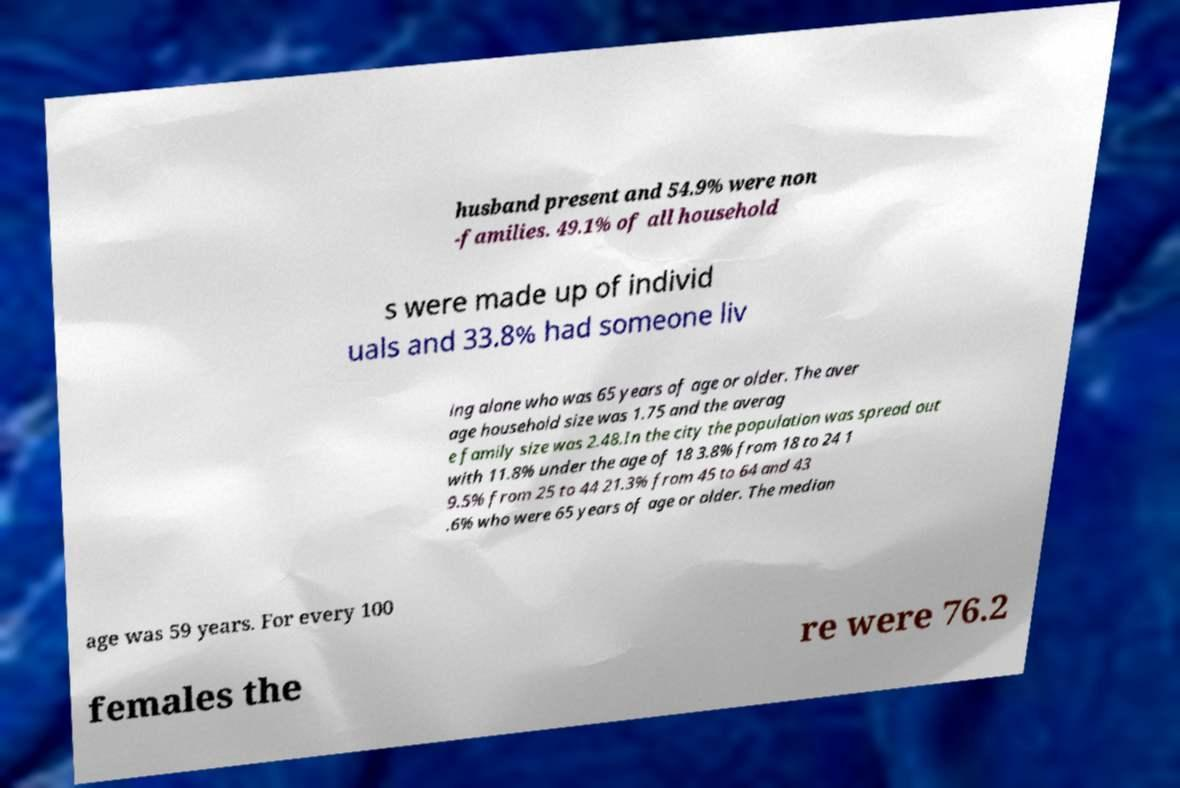Please identify and transcribe the text found in this image. husband present and 54.9% were non -families. 49.1% of all household s were made up of individ uals and 33.8% had someone liv ing alone who was 65 years of age or older. The aver age household size was 1.75 and the averag e family size was 2.48.In the city the population was spread out with 11.8% under the age of 18 3.8% from 18 to 24 1 9.5% from 25 to 44 21.3% from 45 to 64 and 43 .6% who were 65 years of age or older. The median age was 59 years. For every 100 females the re were 76.2 